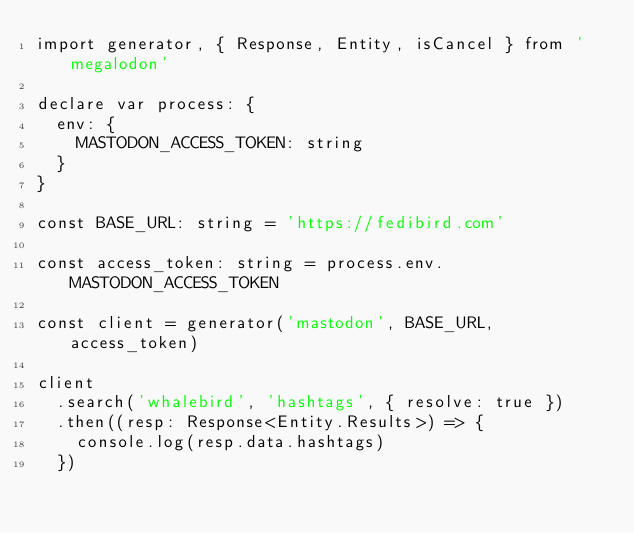Convert code to text. <code><loc_0><loc_0><loc_500><loc_500><_TypeScript_>import generator, { Response, Entity, isCancel } from 'megalodon'

declare var process: {
  env: {
    MASTODON_ACCESS_TOKEN: string
  }
}

const BASE_URL: string = 'https://fedibird.com'

const access_token: string = process.env.MASTODON_ACCESS_TOKEN

const client = generator('mastodon', BASE_URL, access_token)

client
  .search('whalebird', 'hashtags', { resolve: true })
  .then((resp: Response<Entity.Results>) => {
    console.log(resp.data.hashtags)
  })</code> 